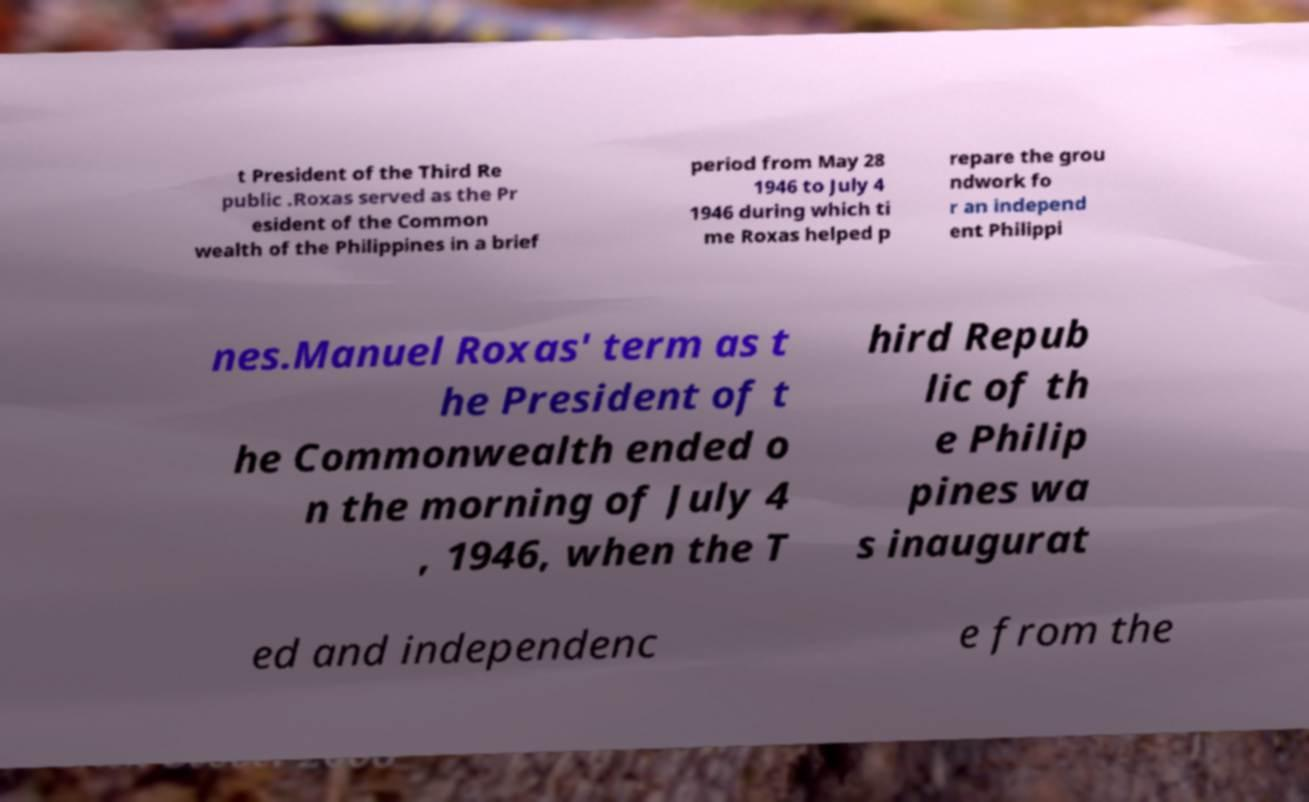Could you assist in decoding the text presented in this image and type it out clearly? t President of the Third Re public .Roxas served as the Pr esident of the Common wealth of the Philippines in a brief period from May 28 1946 to July 4 1946 during which ti me Roxas helped p repare the grou ndwork fo r an independ ent Philippi nes.Manuel Roxas' term as t he President of t he Commonwealth ended o n the morning of July 4 , 1946, when the T hird Repub lic of th e Philip pines wa s inaugurat ed and independenc e from the 